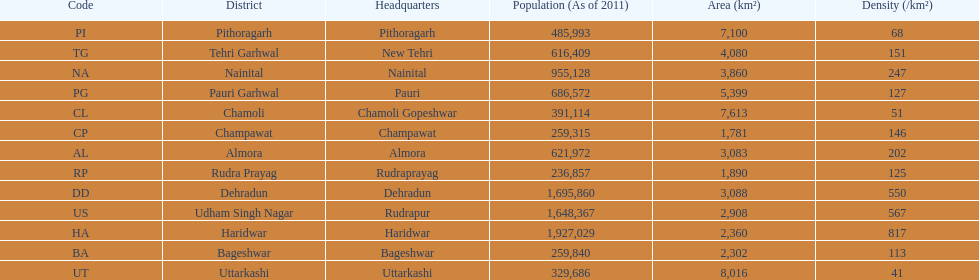How many total districts are there in this area? 13. 